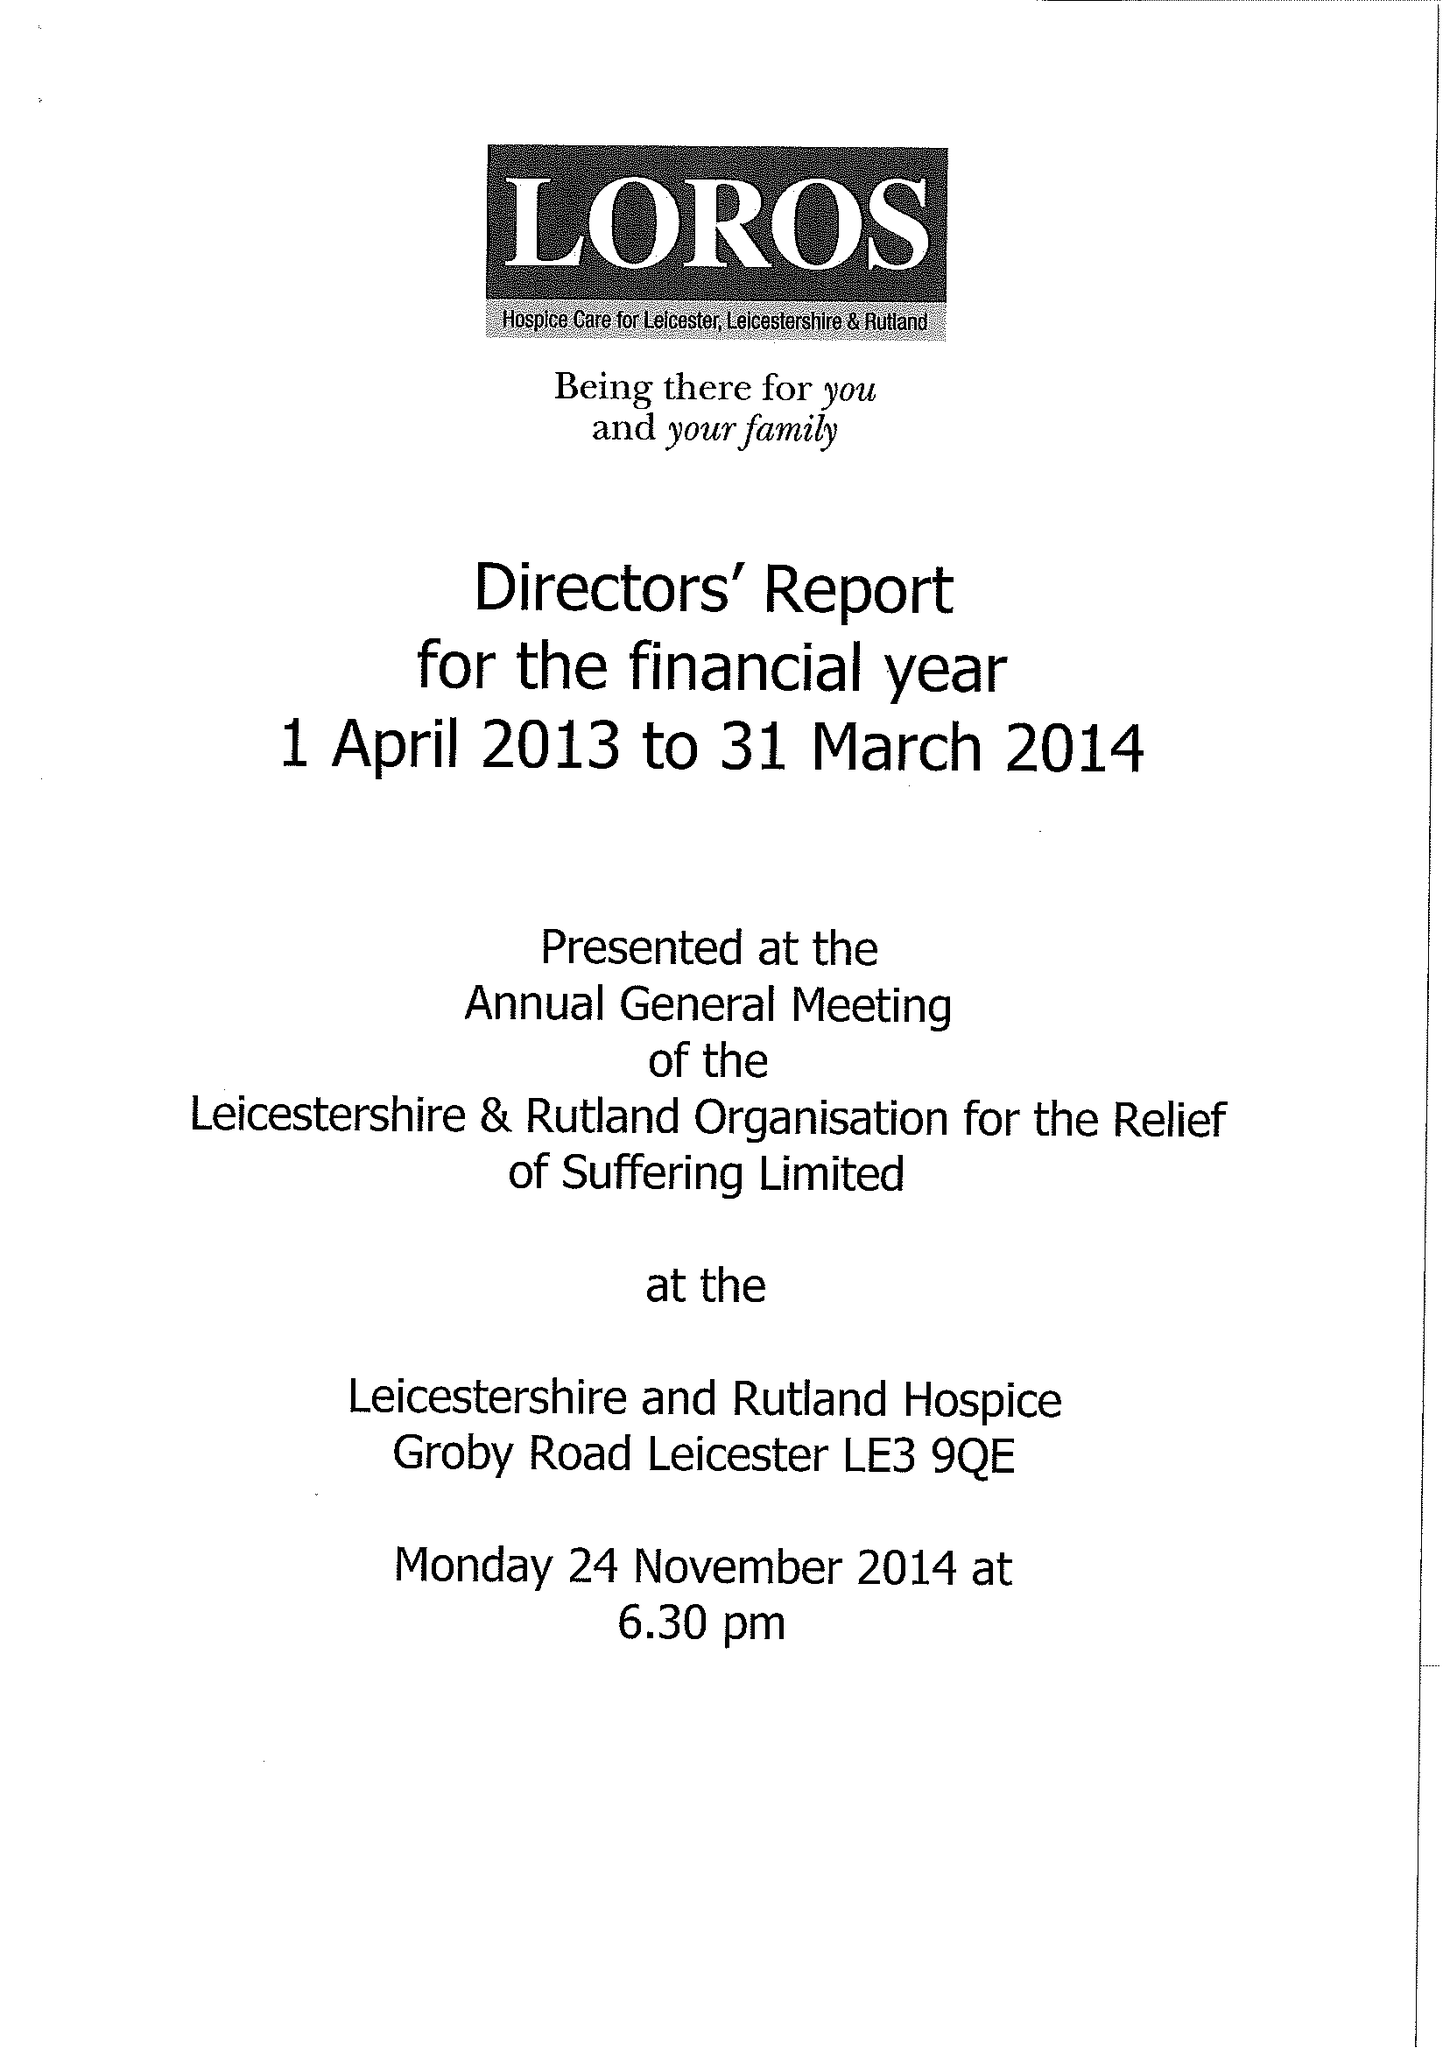What is the value for the charity_number?
Answer the question using a single word or phrase. 506120 